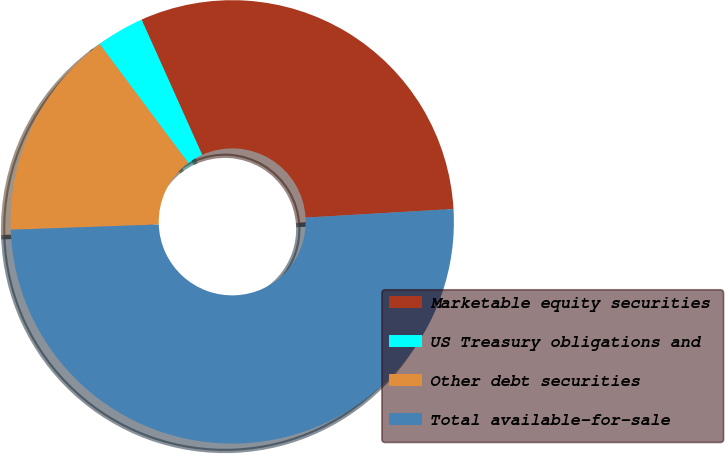<chart> <loc_0><loc_0><loc_500><loc_500><pie_chart><fcel>Marketable equity securities<fcel>US Treasury obligations and<fcel>Other debt securities<fcel>Total available-for-sale<nl><fcel>30.78%<fcel>3.49%<fcel>15.37%<fcel>50.36%<nl></chart> 